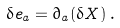Convert formula to latex. <formula><loc_0><loc_0><loc_500><loc_500>\delta { e } _ { a } = \partial _ { a } ( \delta { X } ) \, .</formula> 